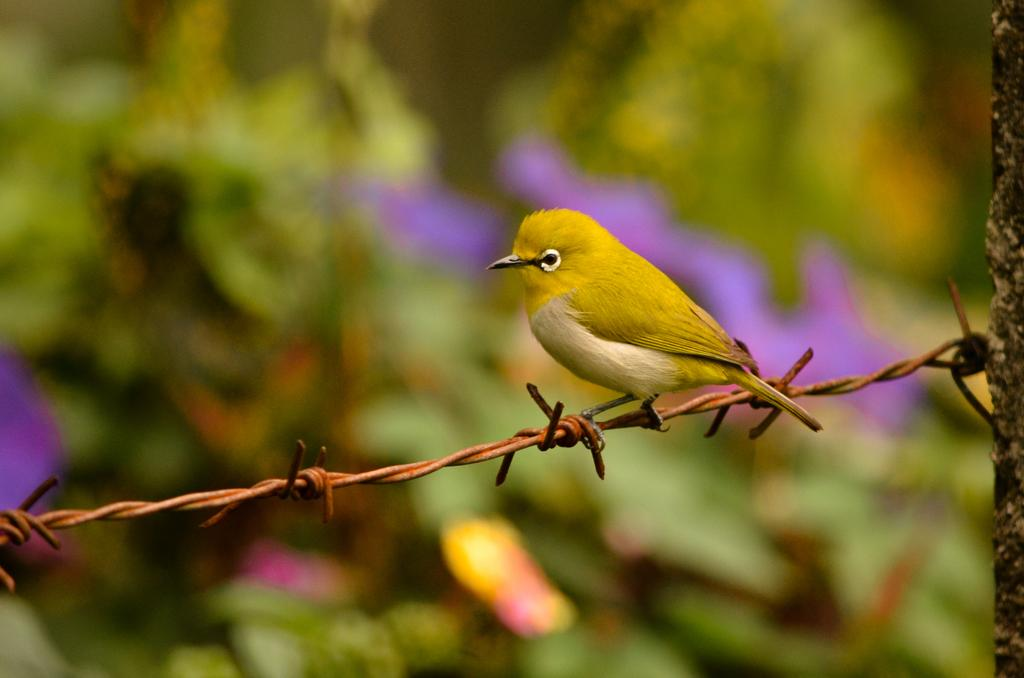What is located on the wires in the image? There is a bird on the wires in the image. Can you describe the background of the image? The background of the image is blurred. What type of chalk is the bird using to draw a rhythmic pattern in the image? There is no chalk or rhythmic pattern present in the image; it features a bird on the wires with a blurred background. 